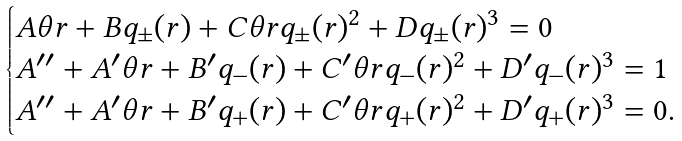<formula> <loc_0><loc_0><loc_500><loc_500>\begin{cases} A \theta r + B q _ { \pm } ( r ) + C \theta r q _ { \pm } ( r ) ^ { 2 } + D q _ { \pm } ( r ) ^ { 3 } = 0 \\ A ^ { \prime \prime } + A ^ { \prime } \theta r + B ^ { \prime } q _ { - } ( r ) + C ^ { \prime } \theta r q _ { - } ( r ) ^ { 2 } + D ^ { \prime } q _ { - } ( r ) ^ { 3 } = 1 \\ A ^ { \prime \prime } + A ^ { \prime } \theta r + B ^ { \prime } q _ { + } ( r ) + C ^ { \prime } \theta r q _ { + } ( r ) ^ { 2 } + D ^ { \prime } q _ { + } ( r ) ^ { 3 } = 0 . \end{cases}</formula> 